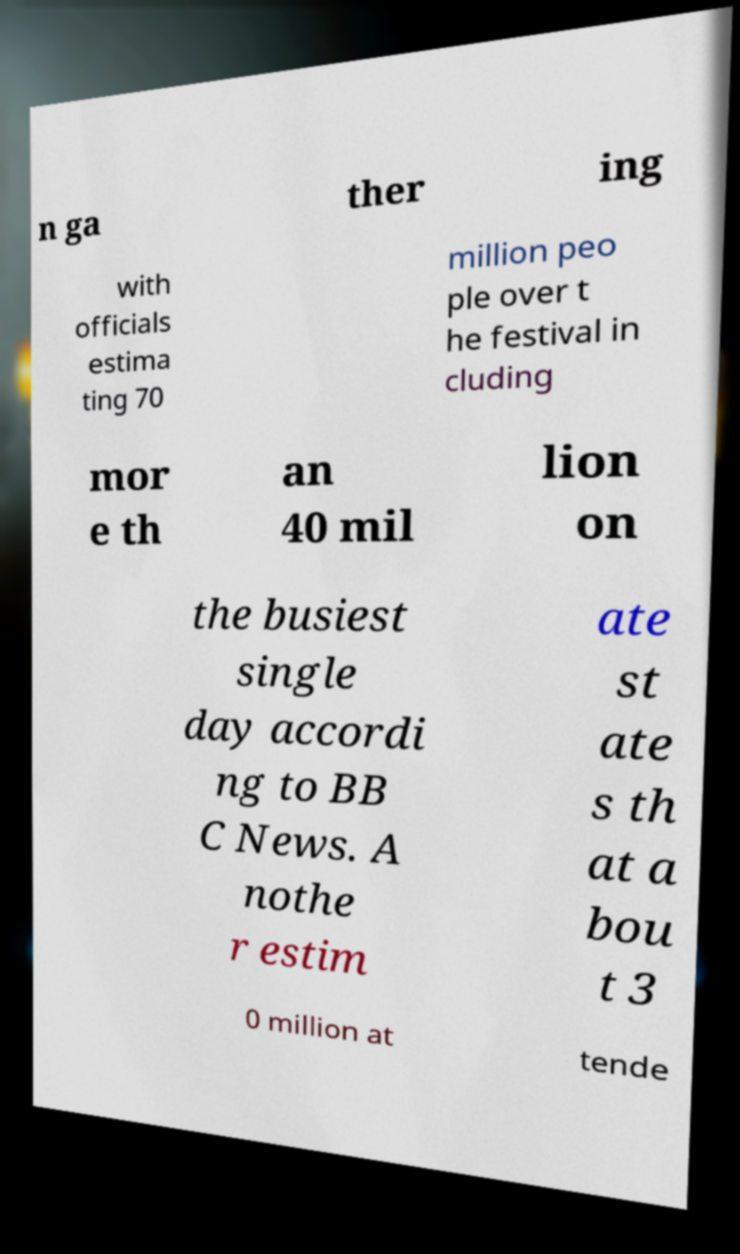Could you extract and type out the text from this image? n ga ther ing with officials estima ting 70 million peo ple over t he festival in cluding mor e th an 40 mil lion on the busiest single day accordi ng to BB C News. A nothe r estim ate st ate s th at a bou t 3 0 million at tende 